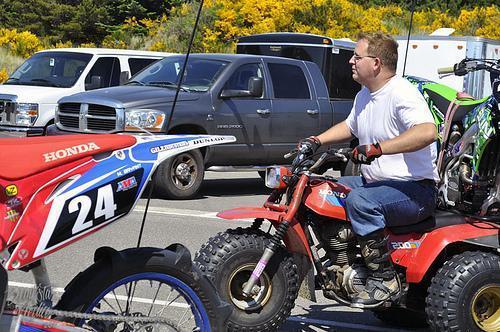How many people are pictured?
Give a very brief answer. 1. 